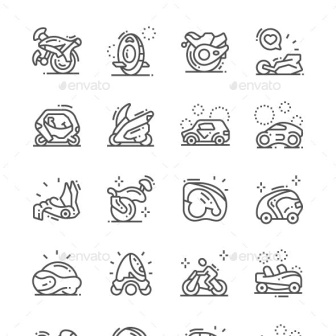Imagine these icons were part of a story, what role would each mode of transportation play? In a fantastical story where each icon represents a vehicle used by a unique character, the motorcycle could be ridden by a daring adventurer navigating through rough terrains. The unicycle might belong to a circus performer known for extraordinary balance and coordination. A mysterious racer might use the motorcycle helmet and racecar to compete in the ultimate interdimensional race. The futuristic enclosed vehicle and other similar designs could be used by a team of inventors exploring new technology. The sled and snowmobile could be part of a thrilling winter adventure tale, while the compact car and sports car might belong to urban heroes zipping through the city's bustling streets. 